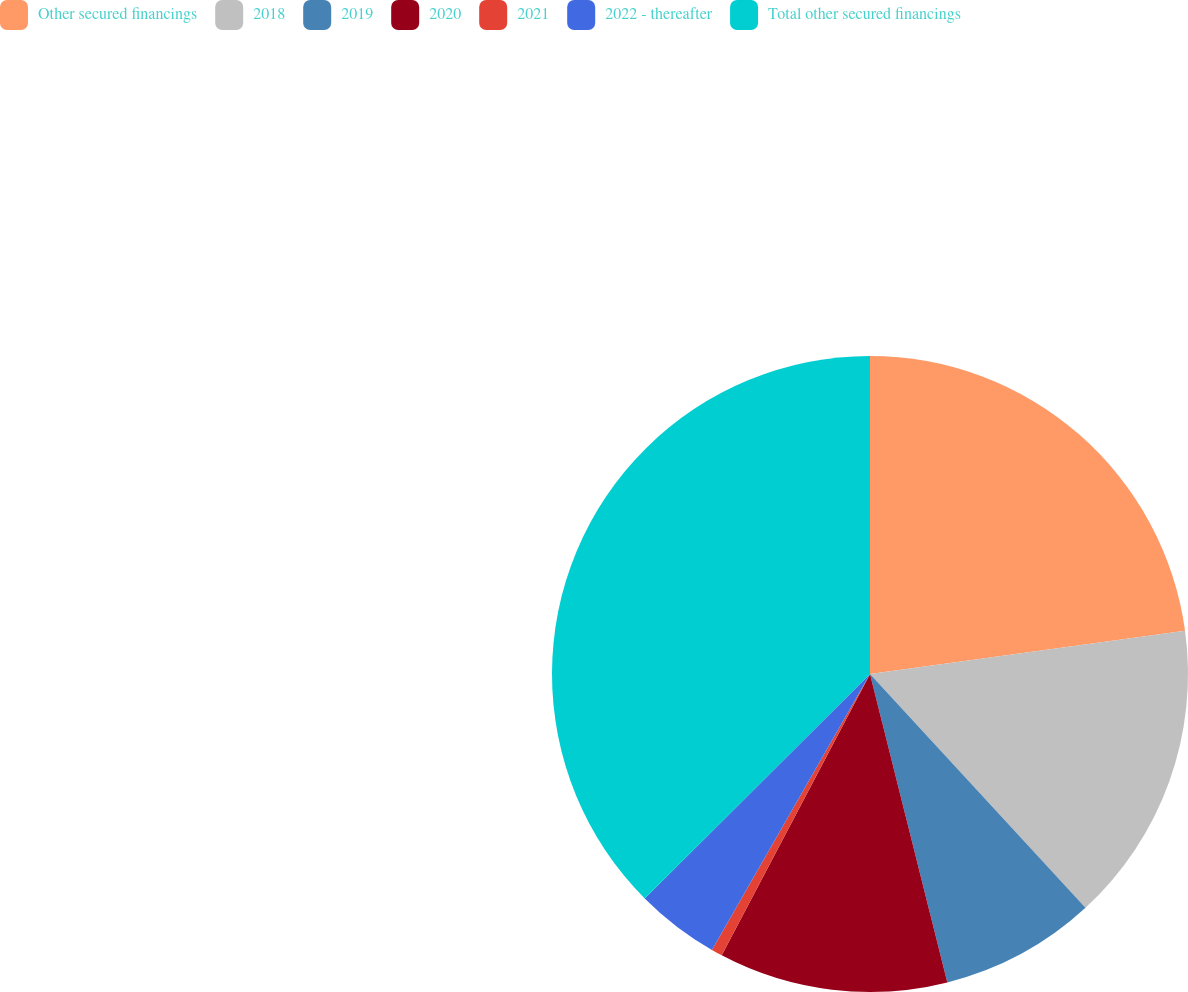<chart> <loc_0><loc_0><loc_500><loc_500><pie_chart><fcel>Other secured financings<fcel>2018<fcel>2019<fcel>2020<fcel>2021<fcel>2022 - thereafter<fcel>Total other secured financings<nl><fcel>22.83%<fcel>15.32%<fcel>7.94%<fcel>11.63%<fcel>0.56%<fcel>4.25%<fcel>37.47%<nl></chart> 